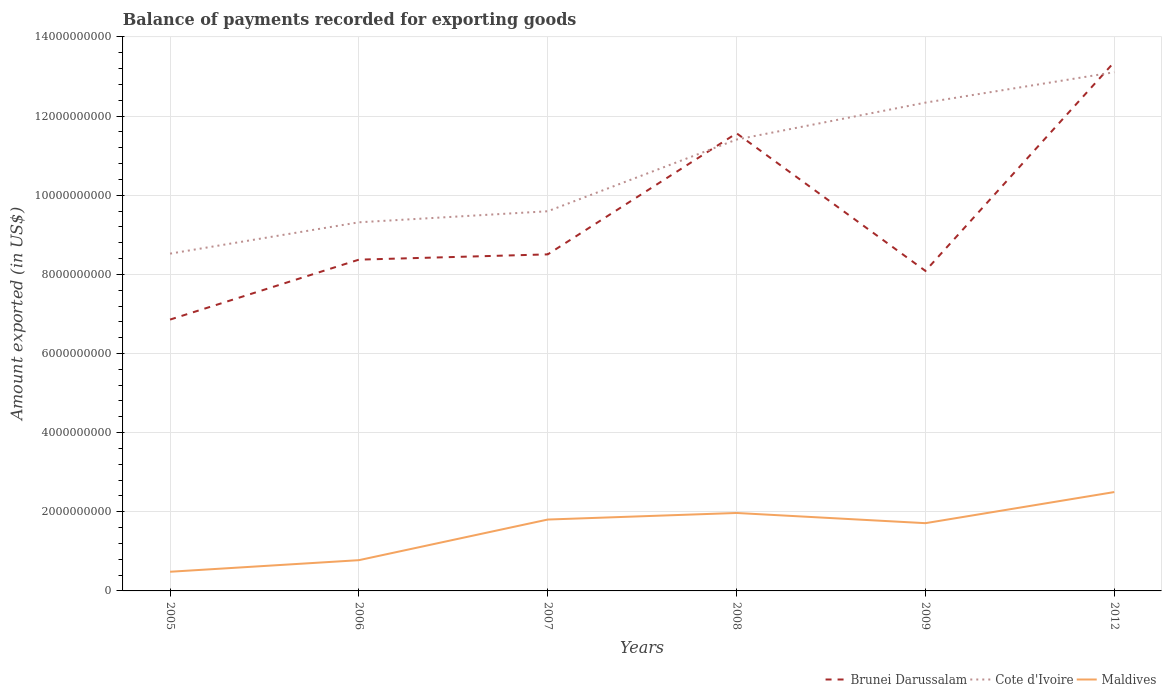How many different coloured lines are there?
Keep it short and to the point. 3. Across all years, what is the maximum amount exported in Cote d'Ivoire?
Offer a very short reply. 8.52e+09. What is the total amount exported in Cote d'Ivoire in the graph?
Provide a short and direct response. -1.07e+09. What is the difference between the highest and the second highest amount exported in Maldives?
Offer a terse response. 2.01e+09. Is the amount exported in Cote d'Ivoire strictly greater than the amount exported in Maldives over the years?
Offer a terse response. No. How many lines are there?
Make the answer very short. 3. What is the difference between two consecutive major ticks on the Y-axis?
Give a very brief answer. 2.00e+09. Are the values on the major ticks of Y-axis written in scientific E-notation?
Make the answer very short. No. How many legend labels are there?
Make the answer very short. 3. What is the title of the graph?
Ensure brevity in your answer.  Balance of payments recorded for exporting goods. What is the label or title of the X-axis?
Give a very brief answer. Years. What is the label or title of the Y-axis?
Your response must be concise. Amount exported (in US$). What is the Amount exported (in US$) of Brunei Darussalam in 2005?
Your answer should be compact. 6.86e+09. What is the Amount exported (in US$) in Cote d'Ivoire in 2005?
Your answer should be very brief. 8.52e+09. What is the Amount exported (in US$) of Maldives in 2005?
Provide a succinct answer. 4.85e+08. What is the Amount exported (in US$) in Brunei Darussalam in 2006?
Provide a short and direct response. 8.37e+09. What is the Amount exported (in US$) of Cote d'Ivoire in 2006?
Give a very brief answer. 9.32e+09. What is the Amount exported (in US$) in Maldives in 2006?
Keep it short and to the point. 7.77e+08. What is the Amount exported (in US$) in Brunei Darussalam in 2007?
Your response must be concise. 8.50e+09. What is the Amount exported (in US$) of Cote d'Ivoire in 2007?
Give a very brief answer. 9.59e+09. What is the Amount exported (in US$) in Maldives in 2007?
Make the answer very short. 1.80e+09. What is the Amount exported (in US$) of Brunei Darussalam in 2008?
Ensure brevity in your answer.  1.16e+1. What is the Amount exported (in US$) of Cote d'Ivoire in 2008?
Give a very brief answer. 1.14e+1. What is the Amount exported (in US$) in Maldives in 2008?
Provide a short and direct response. 1.97e+09. What is the Amount exported (in US$) in Brunei Darussalam in 2009?
Offer a terse response. 8.09e+09. What is the Amount exported (in US$) in Cote d'Ivoire in 2009?
Give a very brief answer. 1.23e+1. What is the Amount exported (in US$) of Maldives in 2009?
Your answer should be compact. 1.71e+09. What is the Amount exported (in US$) of Brunei Darussalam in 2012?
Your response must be concise. 1.34e+1. What is the Amount exported (in US$) of Cote d'Ivoire in 2012?
Your response must be concise. 1.31e+1. What is the Amount exported (in US$) of Maldives in 2012?
Make the answer very short. 2.50e+09. Across all years, what is the maximum Amount exported (in US$) in Brunei Darussalam?
Keep it short and to the point. 1.34e+1. Across all years, what is the maximum Amount exported (in US$) of Cote d'Ivoire?
Offer a very short reply. 1.31e+1. Across all years, what is the maximum Amount exported (in US$) of Maldives?
Offer a terse response. 2.50e+09. Across all years, what is the minimum Amount exported (in US$) of Brunei Darussalam?
Offer a terse response. 6.86e+09. Across all years, what is the minimum Amount exported (in US$) in Cote d'Ivoire?
Offer a very short reply. 8.52e+09. Across all years, what is the minimum Amount exported (in US$) of Maldives?
Your response must be concise. 4.85e+08. What is the total Amount exported (in US$) in Brunei Darussalam in the graph?
Provide a short and direct response. 5.67e+1. What is the total Amount exported (in US$) of Cote d'Ivoire in the graph?
Give a very brief answer. 6.43e+1. What is the total Amount exported (in US$) in Maldives in the graph?
Your response must be concise. 9.25e+09. What is the difference between the Amount exported (in US$) in Brunei Darussalam in 2005 and that in 2006?
Your answer should be compact. -1.51e+09. What is the difference between the Amount exported (in US$) in Cote d'Ivoire in 2005 and that in 2006?
Give a very brief answer. -7.92e+08. What is the difference between the Amount exported (in US$) of Maldives in 2005 and that in 2006?
Give a very brief answer. -2.93e+08. What is the difference between the Amount exported (in US$) in Brunei Darussalam in 2005 and that in 2007?
Your response must be concise. -1.65e+09. What is the difference between the Amount exported (in US$) of Cote d'Ivoire in 2005 and that in 2007?
Give a very brief answer. -1.07e+09. What is the difference between the Amount exported (in US$) of Maldives in 2005 and that in 2007?
Offer a very short reply. -1.32e+09. What is the difference between the Amount exported (in US$) in Brunei Darussalam in 2005 and that in 2008?
Provide a succinct answer. -4.71e+09. What is the difference between the Amount exported (in US$) of Cote d'Ivoire in 2005 and that in 2008?
Your response must be concise. -2.88e+09. What is the difference between the Amount exported (in US$) in Maldives in 2005 and that in 2008?
Give a very brief answer. -1.49e+09. What is the difference between the Amount exported (in US$) of Brunei Darussalam in 2005 and that in 2009?
Provide a succinct answer. -1.23e+09. What is the difference between the Amount exported (in US$) of Cote d'Ivoire in 2005 and that in 2009?
Your answer should be compact. -3.82e+09. What is the difference between the Amount exported (in US$) of Maldives in 2005 and that in 2009?
Provide a short and direct response. -1.23e+09. What is the difference between the Amount exported (in US$) of Brunei Darussalam in 2005 and that in 2012?
Give a very brief answer. -6.51e+09. What is the difference between the Amount exported (in US$) in Cote d'Ivoire in 2005 and that in 2012?
Give a very brief answer. -4.58e+09. What is the difference between the Amount exported (in US$) of Maldives in 2005 and that in 2012?
Provide a short and direct response. -2.01e+09. What is the difference between the Amount exported (in US$) of Brunei Darussalam in 2006 and that in 2007?
Your response must be concise. -1.33e+08. What is the difference between the Amount exported (in US$) of Cote d'Ivoire in 2006 and that in 2007?
Your answer should be very brief. -2.79e+08. What is the difference between the Amount exported (in US$) of Maldives in 2006 and that in 2007?
Provide a succinct answer. -1.03e+09. What is the difference between the Amount exported (in US$) of Brunei Darussalam in 2006 and that in 2008?
Offer a terse response. -3.19e+09. What is the difference between the Amount exported (in US$) of Cote d'Ivoire in 2006 and that in 2008?
Provide a short and direct response. -2.09e+09. What is the difference between the Amount exported (in US$) in Maldives in 2006 and that in 2008?
Provide a succinct answer. -1.19e+09. What is the difference between the Amount exported (in US$) of Brunei Darussalam in 2006 and that in 2009?
Your response must be concise. 2.85e+08. What is the difference between the Amount exported (in US$) in Cote d'Ivoire in 2006 and that in 2009?
Provide a short and direct response. -3.02e+09. What is the difference between the Amount exported (in US$) in Maldives in 2006 and that in 2009?
Give a very brief answer. -9.35e+08. What is the difference between the Amount exported (in US$) in Brunei Darussalam in 2006 and that in 2012?
Your answer should be compact. -4.99e+09. What is the difference between the Amount exported (in US$) in Cote d'Ivoire in 2006 and that in 2012?
Give a very brief answer. -3.79e+09. What is the difference between the Amount exported (in US$) in Maldives in 2006 and that in 2012?
Offer a terse response. -1.72e+09. What is the difference between the Amount exported (in US$) in Brunei Darussalam in 2007 and that in 2008?
Keep it short and to the point. -3.06e+09. What is the difference between the Amount exported (in US$) in Cote d'Ivoire in 2007 and that in 2008?
Your answer should be very brief. -1.81e+09. What is the difference between the Amount exported (in US$) of Maldives in 2007 and that in 2008?
Provide a succinct answer. -1.66e+08. What is the difference between the Amount exported (in US$) in Brunei Darussalam in 2007 and that in 2009?
Make the answer very short. 4.18e+08. What is the difference between the Amount exported (in US$) of Cote d'Ivoire in 2007 and that in 2009?
Ensure brevity in your answer.  -2.75e+09. What is the difference between the Amount exported (in US$) of Maldives in 2007 and that in 2009?
Your response must be concise. 9.17e+07. What is the difference between the Amount exported (in US$) of Brunei Darussalam in 2007 and that in 2012?
Offer a very short reply. -4.86e+09. What is the difference between the Amount exported (in US$) of Cote d'Ivoire in 2007 and that in 2012?
Offer a very short reply. -3.51e+09. What is the difference between the Amount exported (in US$) of Maldives in 2007 and that in 2012?
Your answer should be compact. -6.95e+08. What is the difference between the Amount exported (in US$) of Brunei Darussalam in 2008 and that in 2009?
Offer a very short reply. 3.48e+09. What is the difference between the Amount exported (in US$) of Cote d'Ivoire in 2008 and that in 2009?
Give a very brief answer. -9.33e+08. What is the difference between the Amount exported (in US$) in Maldives in 2008 and that in 2009?
Make the answer very short. 2.58e+08. What is the difference between the Amount exported (in US$) of Brunei Darussalam in 2008 and that in 2012?
Offer a very short reply. -1.80e+09. What is the difference between the Amount exported (in US$) in Cote d'Ivoire in 2008 and that in 2012?
Offer a very short reply. -1.70e+09. What is the difference between the Amount exported (in US$) in Maldives in 2008 and that in 2012?
Your answer should be compact. -5.29e+08. What is the difference between the Amount exported (in US$) in Brunei Darussalam in 2009 and that in 2012?
Give a very brief answer. -5.28e+09. What is the difference between the Amount exported (in US$) of Cote d'Ivoire in 2009 and that in 2012?
Ensure brevity in your answer.  -7.68e+08. What is the difference between the Amount exported (in US$) of Maldives in 2009 and that in 2012?
Offer a terse response. -7.86e+08. What is the difference between the Amount exported (in US$) in Brunei Darussalam in 2005 and the Amount exported (in US$) in Cote d'Ivoire in 2006?
Ensure brevity in your answer.  -2.46e+09. What is the difference between the Amount exported (in US$) in Brunei Darussalam in 2005 and the Amount exported (in US$) in Maldives in 2006?
Provide a succinct answer. 6.08e+09. What is the difference between the Amount exported (in US$) of Cote d'Ivoire in 2005 and the Amount exported (in US$) of Maldives in 2006?
Provide a succinct answer. 7.75e+09. What is the difference between the Amount exported (in US$) in Brunei Darussalam in 2005 and the Amount exported (in US$) in Cote d'Ivoire in 2007?
Your response must be concise. -2.74e+09. What is the difference between the Amount exported (in US$) of Brunei Darussalam in 2005 and the Amount exported (in US$) of Maldives in 2007?
Give a very brief answer. 5.05e+09. What is the difference between the Amount exported (in US$) of Cote d'Ivoire in 2005 and the Amount exported (in US$) of Maldives in 2007?
Ensure brevity in your answer.  6.72e+09. What is the difference between the Amount exported (in US$) of Brunei Darussalam in 2005 and the Amount exported (in US$) of Cote d'Ivoire in 2008?
Keep it short and to the point. -4.55e+09. What is the difference between the Amount exported (in US$) in Brunei Darussalam in 2005 and the Amount exported (in US$) in Maldives in 2008?
Your answer should be compact. 4.89e+09. What is the difference between the Amount exported (in US$) of Cote d'Ivoire in 2005 and the Amount exported (in US$) of Maldives in 2008?
Provide a succinct answer. 6.55e+09. What is the difference between the Amount exported (in US$) of Brunei Darussalam in 2005 and the Amount exported (in US$) of Cote d'Ivoire in 2009?
Your answer should be compact. -5.48e+09. What is the difference between the Amount exported (in US$) in Brunei Darussalam in 2005 and the Amount exported (in US$) in Maldives in 2009?
Offer a very short reply. 5.14e+09. What is the difference between the Amount exported (in US$) of Cote d'Ivoire in 2005 and the Amount exported (in US$) of Maldives in 2009?
Give a very brief answer. 6.81e+09. What is the difference between the Amount exported (in US$) in Brunei Darussalam in 2005 and the Amount exported (in US$) in Cote d'Ivoire in 2012?
Make the answer very short. -6.25e+09. What is the difference between the Amount exported (in US$) in Brunei Darussalam in 2005 and the Amount exported (in US$) in Maldives in 2012?
Offer a very short reply. 4.36e+09. What is the difference between the Amount exported (in US$) in Cote d'Ivoire in 2005 and the Amount exported (in US$) in Maldives in 2012?
Make the answer very short. 6.02e+09. What is the difference between the Amount exported (in US$) in Brunei Darussalam in 2006 and the Amount exported (in US$) in Cote d'Ivoire in 2007?
Give a very brief answer. -1.22e+09. What is the difference between the Amount exported (in US$) of Brunei Darussalam in 2006 and the Amount exported (in US$) of Maldives in 2007?
Your answer should be very brief. 6.57e+09. What is the difference between the Amount exported (in US$) in Cote d'Ivoire in 2006 and the Amount exported (in US$) in Maldives in 2007?
Your response must be concise. 7.51e+09. What is the difference between the Amount exported (in US$) in Brunei Darussalam in 2006 and the Amount exported (in US$) in Cote d'Ivoire in 2008?
Provide a short and direct response. -3.04e+09. What is the difference between the Amount exported (in US$) of Brunei Darussalam in 2006 and the Amount exported (in US$) of Maldives in 2008?
Ensure brevity in your answer.  6.40e+09. What is the difference between the Amount exported (in US$) of Cote d'Ivoire in 2006 and the Amount exported (in US$) of Maldives in 2008?
Make the answer very short. 7.35e+09. What is the difference between the Amount exported (in US$) in Brunei Darussalam in 2006 and the Amount exported (in US$) in Cote d'Ivoire in 2009?
Your response must be concise. -3.97e+09. What is the difference between the Amount exported (in US$) of Brunei Darussalam in 2006 and the Amount exported (in US$) of Maldives in 2009?
Your answer should be compact. 6.66e+09. What is the difference between the Amount exported (in US$) of Cote d'Ivoire in 2006 and the Amount exported (in US$) of Maldives in 2009?
Your answer should be compact. 7.60e+09. What is the difference between the Amount exported (in US$) in Brunei Darussalam in 2006 and the Amount exported (in US$) in Cote d'Ivoire in 2012?
Keep it short and to the point. -4.74e+09. What is the difference between the Amount exported (in US$) of Brunei Darussalam in 2006 and the Amount exported (in US$) of Maldives in 2012?
Your answer should be compact. 5.87e+09. What is the difference between the Amount exported (in US$) of Cote d'Ivoire in 2006 and the Amount exported (in US$) of Maldives in 2012?
Keep it short and to the point. 6.82e+09. What is the difference between the Amount exported (in US$) in Brunei Darussalam in 2007 and the Amount exported (in US$) in Cote d'Ivoire in 2008?
Ensure brevity in your answer.  -2.90e+09. What is the difference between the Amount exported (in US$) in Brunei Darussalam in 2007 and the Amount exported (in US$) in Maldives in 2008?
Give a very brief answer. 6.54e+09. What is the difference between the Amount exported (in US$) of Cote d'Ivoire in 2007 and the Amount exported (in US$) of Maldives in 2008?
Your response must be concise. 7.62e+09. What is the difference between the Amount exported (in US$) in Brunei Darussalam in 2007 and the Amount exported (in US$) in Cote d'Ivoire in 2009?
Your response must be concise. -3.83e+09. What is the difference between the Amount exported (in US$) of Brunei Darussalam in 2007 and the Amount exported (in US$) of Maldives in 2009?
Your answer should be very brief. 6.79e+09. What is the difference between the Amount exported (in US$) of Cote d'Ivoire in 2007 and the Amount exported (in US$) of Maldives in 2009?
Your answer should be very brief. 7.88e+09. What is the difference between the Amount exported (in US$) of Brunei Darussalam in 2007 and the Amount exported (in US$) of Cote d'Ivoire in 2012?
Offer a very short reply. -4.60e+09. What is the difference between the Amount exported (in US$) of Brunei Darussalam in 2007 and the Amount exported (in US$) of Maldives in 2012?
Keep it short and to the point. 6.01e+09. What is the difference between the Amount exported (in US$) in Cote d'Ivoire in 2007 and the Amount exported (in US$) in Maldives in 2012?
Keep it short and to the point. 7.10e+09. What is the difference between the Amount exported (in US$) of Brunei Darussalam in 2008 and the Amount exported (in US$) of Cote d'Ivoire in 2009?
Give a very brief answer. -7.75e+08. What is the difference between the Amount exported (in US$) in Brunei Darussalam in 2008 and the Amount exported (in US$) in Maldives in 2009?
Make the answer very short. 9.85e+09. What is the difference between the Amount exported (in US$) of Cote d'Ivoire in 2008 and the Amount exported (in US$) of Maldives in 2009?
Keep it short and to the point. 9.69e+09. What is the difference between the Amount exported (in US$) in Brunei Darussalam in 2008 and the Amount exported (in US$) in Cote d'Ivoire in 2012?
Offer a very short reply. -1.54e+09. What is the difference between the Amount exported (in US$) in Brunei Darussalam in 2008 and the Amount exported (in US$) in Maldives in 2012?
Offer a very short reply. 9.07e+09. What is the difference between the Amount exported (in US$) of Cote d'Ivoire in 2008 and the Amount exported (in US$) of Maldives in 2012?
Keep it short and to the point. 8.91e+09. What is the difference between the Amount exported (in US$) in Brunei Darussalam in 2009 and the Amount exported (in US$) in Cote d'Ivoire in 2012?
Ensure brevity in your answer.  -5.02e+09. What is the difference between the Amount exported (in US$) of Brunei Darussalam in 2009 and the Amount exported (in US$) of Maldives in 2012?
Give a very brief answer. 5.59e+09. What is the difference between the Amount exported (in US$) of Cote d'Ivoire in 2009 and the Amount exported (in US$) of Maldives in 2012?
Make the answer very short. 9.84e+09. What is the average Amount exported (in US$) in Brunei Darussalam per year?
Provide a succinct answer. 9.46e+09. What is the average Amount exported (in US$) of Cote d'Ivoire per year?
Offer a terse response. 1.07e+1. What is the average Amount exported (in US$) of Maldives per year?
Keep it short and to the point. 1.54e+09. In the year 2005, what is the difference between the Amount exported (in US$) in Brunei Darussalam and Amount exported (in US$) in Cote d'Ivoire?
Your answer should be compact. -1.67e+09. In the year 2005, what is the difference between the Amount exported (in US$) of Brunei Darussalam and Amount exported (in US$) of Maldives?
Your answer should be very brief. 6.37e+09. In the year 2005, what is the difference between the Amount exported (in US$) of Cote d'Ivoire and Amount exported (in US$) of Maldives?
Give a very brief answer. 8.04e+09. In the year 2006, what is the difference between the Amount exported (in US$) of Brunei Darussalam and Amount exported (in US$) of Cote d'Ivoire?
Make the answer very short. -9.44e+08. In the year 2006, what is the difference between the Amount exported (in US$) in Brunei Darussalam and Amount exported (in US$) in Maldives?
Your answer should be very brief. 7.59e+09. In the year 2006, what is the difference between the Amount exported (in US$) of Cote d'Ivoire and Amount exported (in US$) of Maldives?
Your answer should be very brief. 8.54e+09. In the year 2007, what is the difference between the Amount exported (in US$) in Brunei Darussalam and Amount exported (in US$) in Cote d'Ivoire?
Give a very brief answer. -1.09e+09. In the year 2007, what is the difference between the Amount exported (in US$) in Brunei Darussalam and Amount exported (in US$) in Maldives?
Your response must be concise. 6.70e+09. In the year 2007, what is the difference between the Amount exported (in US$) in Cote d'Ivoire and Amount exported (in US$) in Maldives?
Provide a short and direct response. 7.79e+09. In the year 2008, what is the difference between the Amount exported (in US$) of Brunei Darussalam and Amount exported (in US$) of Cote d'Ivoire?
Provide a succinct answer. 1.58e+08. In the year 2008, what is the difference between the Amount exported (in US$) of Brunei Darussalam and Amount exported (in US$) of Maldives?
Provide a short and direct response. 9.60e+09. In the year 2008, what is the difference between the Amount exported (in US$) of Cote d'Ivoire and Amount exported (in US$) of Maldives?
Your answer should be compact. 9.44e+09. In the year 2009, what is the difference between the Amount exported (in US$) of Brunei Darussalam and Amount exported (in US$) of Cote d'Ivoire?
Give a very brief answer. -4.25e+09. In the year 2009, what is the difference between the Amount exported (in US$) in Brunei Darussalam and Amount exported (in US$) in Maldives?
Offer a very short reply. 6.37e+09. In the year 2009, what is the difference between the Amount exported (in US$) in Cote d'Ivoire and Amount exported (in US$) in Maldives?
Provide a short and direct response. 1.06e+1. In the year 2012, what is the difference between the Amount exported (in US$) of Brunei Darussalam and Amount exported (in US$) of Cote d'Ivoire?
Offer a very short reply. 2.57e+08. In the year 2012, what is the difference between the Amount exported (in US$) in Brunei Darussalam and Amount exported (in US$) in Maldives?
Your answer should be very brief. 1.09e+1. In the year 2012, what is the difference between the Amount exported (in US$) of Cote d'Ivoire and Amount exported (in US$) of Maldives?
Your response must be concise. 1.06e+1. What is the ratio of the Amount exported (in US$) in Brunei Darussalam in 2005 to that in 2006?
Your answer should be compact. 0.82. What is the ratio of the Amount exported (in US$) of Cote d'Ivoire in 2005 to that in 2006?
Ensure brevity in your answer.  0.92. What is the ratio of the Amount exported (in US$) of Maldives in 2005 to that in 2006?
Give a very brief answer. 0.62. What is the ratio of the Amount exported (in US$) of Brunei Darussalam in 2005 to that in 2007?
Your answer should be compact. 0.81. What is the ratio of the Amount exported (in US$) in Cote d'Ivoire in 2005 to that in 2007?
Make the answer very short. 0.89. What is the ratio of the Amount exported (in US$) of Maldives in 2005 to that in 2007?
Your answer should be very brief. 0.27. What is the ratio of the Amount exported (in US$) in Brunei Darussalam in 2005 to that in 2008?
Keep it short and to the point. 0.59. What is the ratio of the Amount exported (in US$) in Cote d'Ivoire in 2005 to that in 2008?
Give a very brief answer. 0.75. What is the ratio of the Amount exported (in US$) in Maldives in 2005 to that in 2008?
Your response must be concise. 0.25. What is the ratio of the Amount exported (in US$) in Brunei Darussalam in 2005 to that in 2009?
Make the answer very short. 0.85. What is the ratio of the Amount exported (in US$) of Cote d'Ivoire in 2005 to that in 2009?
Provide a succinct answer. 0.69. What is the ratio of the Amount exported (in US$) of Maldives in 2005 to that in 2009?
Offer a very short reply. 0.28. What is the ratio of the Amount exported (in US$) of Brunei Darussalam in 2005 to that in 2012?
Offer a terse response. 0.51. What is the ratio of the Amount exported (in US$) in Cote d'Ivoire in 2005 to that in 2012?
Your response must be concise. 0.65. What is the ratio of the Amount exported (in US$) in Maldives in 2005 to that in 2012?
Your answer should be very brief. 0.19. What is the ratio of the Amount exported (in US$) of Brunei Darussalam in 2006 to that in 2007?
Keep it short and to the point. 0.98. What is the ratio of the Amount exported (in US$) of Cote d'Ivoire in 2006 to that in 2007?
Provide a short and direct response. 0.97. What is the ratio of the Amount exported (in US$) in Maldives in 2006 to that in 2007?
Provide a short and direct response. 0.43. What is the ratio of the Amount exported (in US$) of Brunei Darussalam in 2006 to that in 2008?
Offer a terse response. 0.72. What is the ratio of the Amount exported (in US$) in Cote d'Ivoire in 2006 to that in 2008?
Offer a very short reply. 0.82. What is the ratio of the Amount exported (in US$) of Maldives in 2006 to that in 2008?
Ensure brevity in your answer.  0.39. What is the ratio of the Amount exported (in US$) in Brunei Darussalam in 2006 to that in 2009?
Give a very brief answer. 1.04. What is the ratio of the Amount exported (in US$) in Cote d'Ivoire in 2006 to that in 2009?
Provide a succinct answer. 0.75. What is the ratio of the Amount exported (in US$) in Maldives in 2006 to that in 2009?
Your response must be concise. 0.45. What is the ratio of the Amount exported (in US$) of Brunei Darussalam in 2006 to that in 2012?
Make the answer very short. 0.63. What is the ratio of the Amount exported (in US$) in Cote d'Ivoire in 2006 to that in 2012?
Keep it short and to the point. 0.71. What is the ratio of the Amount exported (in US$) in Maldives in 2006 to that in 2012?
Offer a very short reply. 0.31. What is the ratio of the Amount exported (in US$) in Brunei Darussalam in 2007 to that in 2008?
Ensure brevity in your answer.  0.74. What is the ratio of the Amount exported (in US$) in Cote d'Ivoire in 2007 to that in 2008?
Provide a short and direct response. 0.84. What is the ratio of the Amount exported (in US$) in Maldives in 2007 to that in 2008?
Make the answer very short. 0.92. What is the ratio of the Amount exported (in US$) in Brunei Darussalam in 2007 to that in 2009?
Your response must be concise. 1.05. What is the ratio of the Amount exported (in US$) in Cote d'Ivoire in 2007 to that in 2009?
Your answer should be compact. 0.78. What is the ratio of the Amount exported (in US$) in Maldives in 2007 to that in 2009?
Give a very brief answer. 1.05. What is the ratio of the Amount exported (in US$) of Brunei Darussalam in 2007 to that in 2012?
Your response must be concise. 0.64. What is the ratio of the Amount exported (in US$) of Cote d'Ivoire in 2007 to that in 2012?
Ensure brevity in your answer.  0.73. What is the ratio of the Amount exported (in US$) of Maldives in 2007 to that in 2012?
Keep it short and to the point. 0.72. What is the ratio of the Amount exported (in US$) in Brunei Darussalam in 2008 to that in 2009?
Offer a very short reply. 1.43. What is the ratio of the Amount exported (in US$) in Cote d'Ivoire in 2008 to that in 2009?
Offer a terse response. 0.92. What is the ratio of the Amount exported (in US$) of Maldives in 2008 to that in 2009?
Offer a very short reply. 1.15. What is the ratio of the Amount exported (in US$) in Brunei Darussalam in 2008 to that in 2012?
Your answer should be very brief. 0.87. What is the ratio of the Amount exported (in US$) in Cote d'Ivoire in 2008 to that in 2012?
Ensure brevity in your answer.  0.87. What is the ratio of the Amount exported (in US$) of Maldives in 2008 to that in 2012?
Offer a very short reply. 0.79. What is the ratio of the Amount exported (in US$) of Brunei Darussalam in 2009 to that in 2012?
Offer a very short reply. 0.61. What is the ratio of the Amount exported (in US$) of Cote d'Ivoire in 2009 to that in 2012?
Your response must be concise. 0.94. What is the ratio of the Amount exported (in US$) of Maldives in 2009 to that in 2012?
Keep it short and to the point. 0.69. What is the difference between the highest and the second highest Amount exported (in US$) of Brunei Darussalam?
Offer a terse response. 1.80e+09. What is the difference between the highest and the second highest Amount exported (in US$) in Cote d'Ivoire?
Keep it short and to the point. 7.68e+08. What is the difference between the highest and the second highest Amount exported (in US$) in Maldives?
Provide a succinct answer. 5.29e+08. What is the difference between the highest and the lowest Amount exported (in US$) of Brunei Darussalam?
Your answer should be very brief. 6.51e+09. What is the difference between the highest and the lowest Amount exported (in US$) in Cote d'Ivoire?
Offer a terse response. 4.58e+09. What is the difference between the highest and the lowest Amount exported (in US$) in Maldives?
Keep it short and to the point. 2.01e+09. 